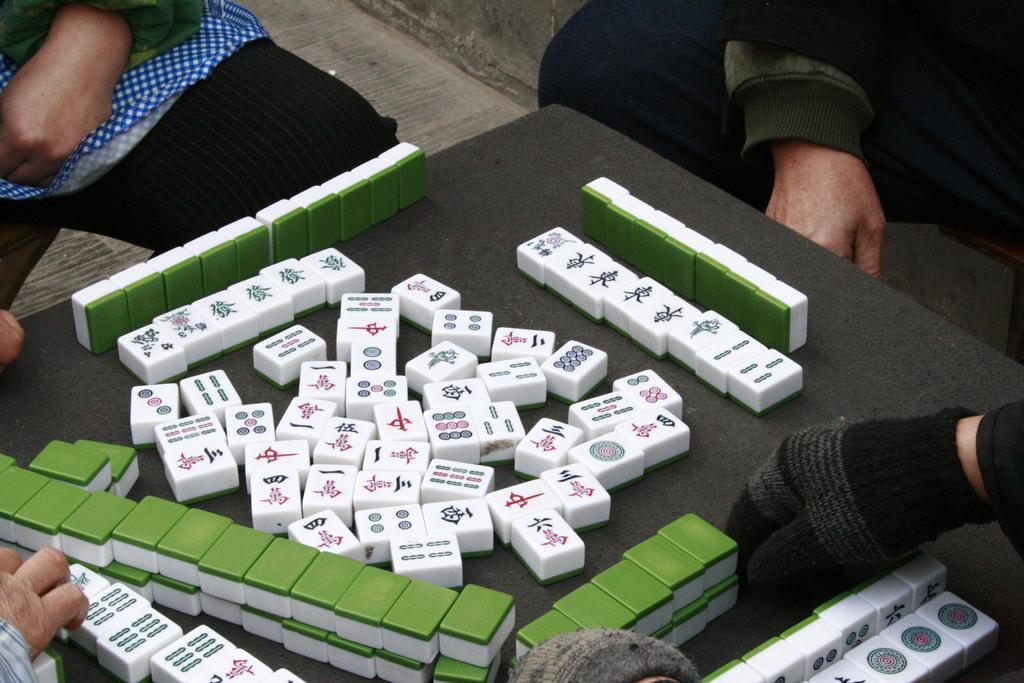Please provide a concise description of this image. In this picture we can see a table in the front, there are hands of two persons at the bottom, we can see two more persons at the top of the picture, these people are playing mahjong game. 